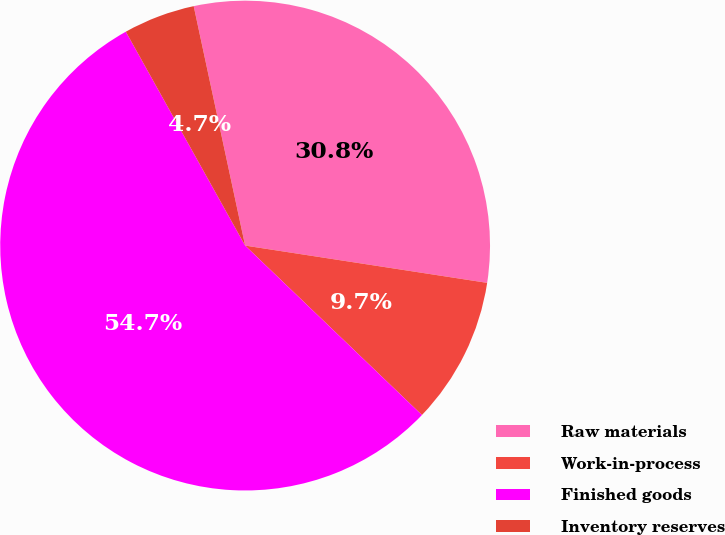Convert chart to OTSL. <chart><loc_0><loc_0><loc_500><loc_500><pie_chart><fcel>Raw materials<fcel>Work-in-process<fcel>Finished goods<fcel>Inventory reserves<nl><fcel>30.8%<fcel>9.73%<fcel>54.74%<fcel>4.73%<nl></chart> 